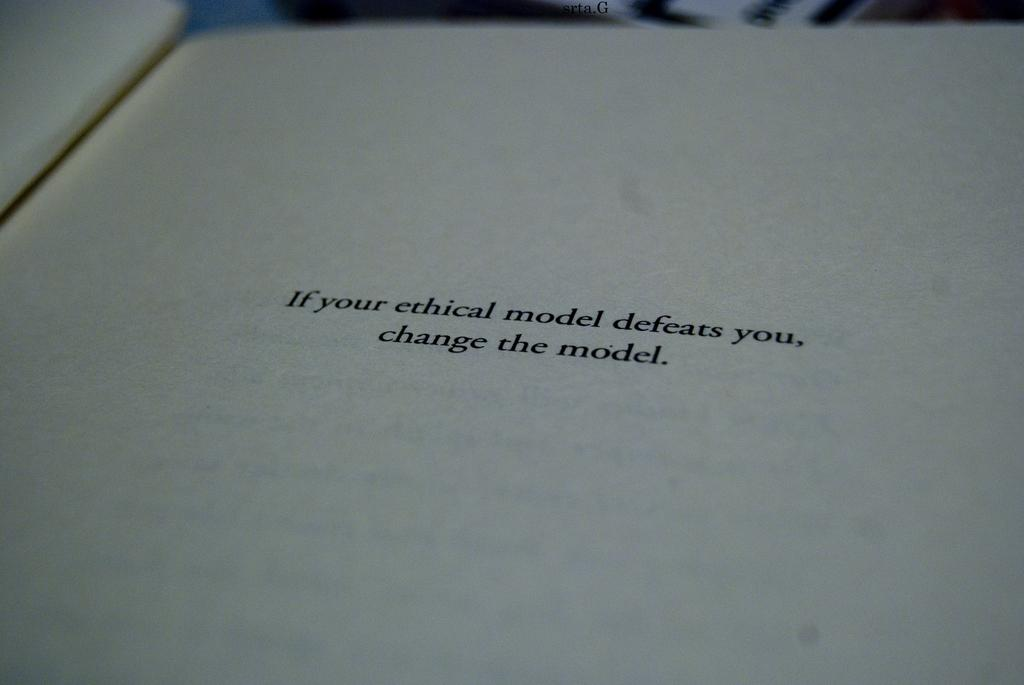<image>
Create a compact narrative representing the image presented. Single white page about what you should do if your ethical model defeats you. 